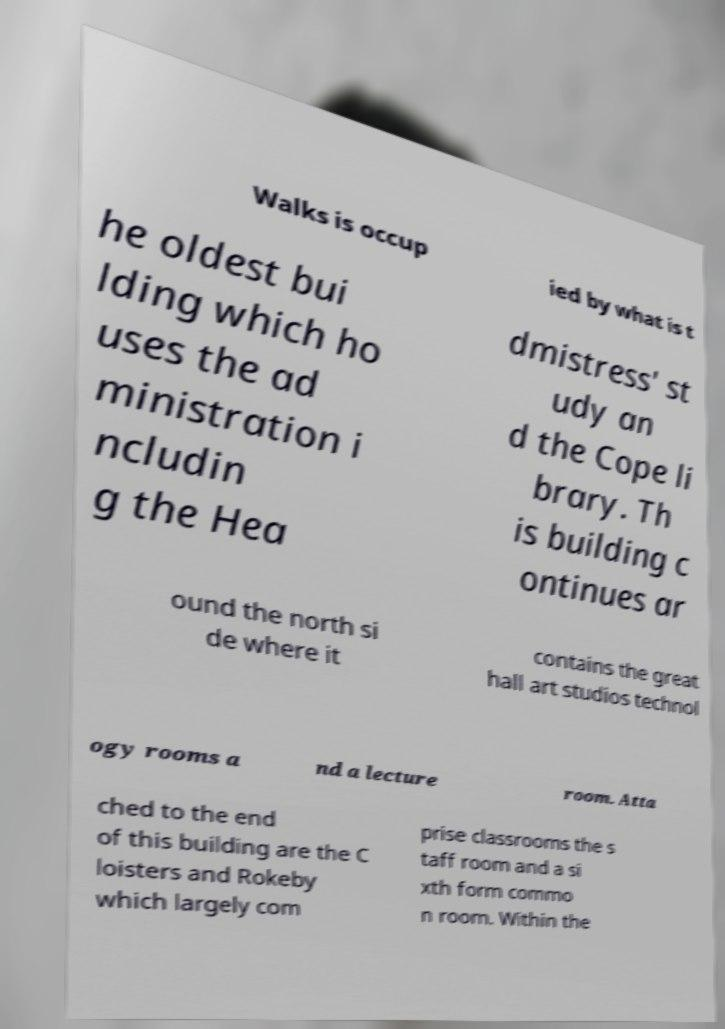I need the written content from this picture converted into text. Can you do that? Walks is occup ied by what is t he oldest bui lding which ho uses the ad ministration i ncludin g the Hea dmistress' st udy an d the Cope li brary. Th is building c ontinues ar ound the north si de where it contains the great hall art studios technol ogy rooms a nd a lecture room. Atta ched to the end of this building are the C loisters and Rokeby which largely com prise classrooms the s taff room and a si xth form commo n room. Within the 